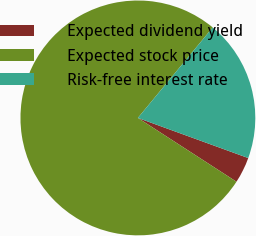Convert chart. <chart><loc_0><loc_0><loc_500><loc_500><pie_chart><fcel>Expected dividend yield<fcel>Expected stock price<fcel>Risk-free interest rate<nl><fcel>3.59%<fcel>76.86%<fcel>19.55%<nl></chart> 